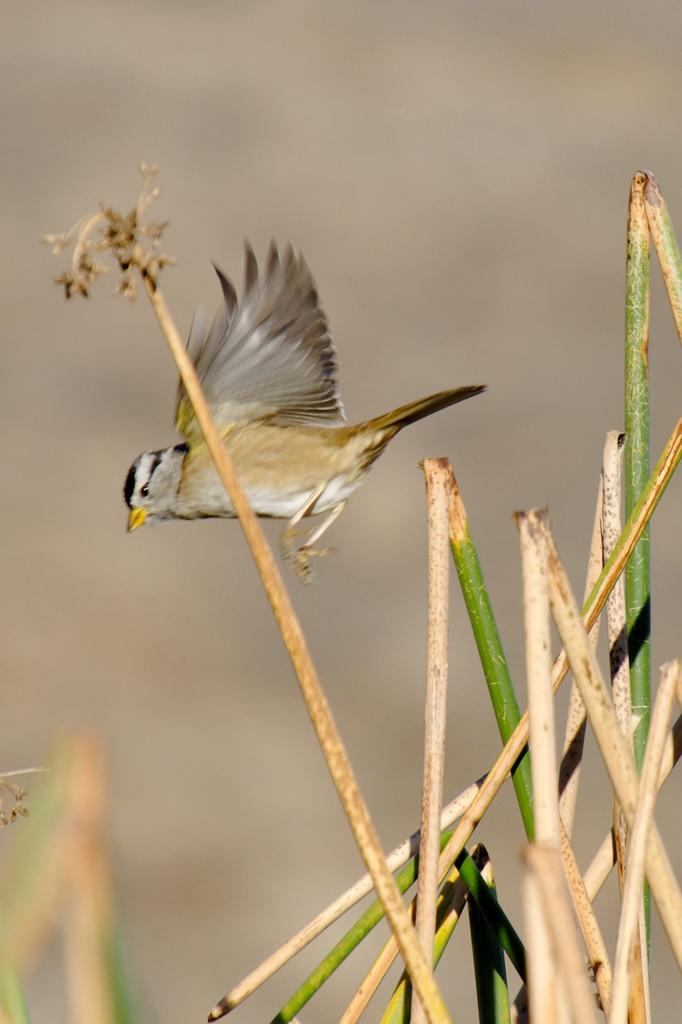What is the main subject of the image? There is a bird flying in the image. Can you describe the background of the image? The background of the image is blurred. What is the bird's tendency to give birth in the image? There is no indication of the bird giving birth in the image, and therefore no such information can be provided. 